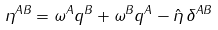<formula> <loc_0><loc_0><loc_500><loc_500>\eta ^ { A B } = \omega ^ { A } q ^ { B } + \omega ^ { B } q ^ { A } - \hat { \eta } \, \delta ^ { A B }</formula> 